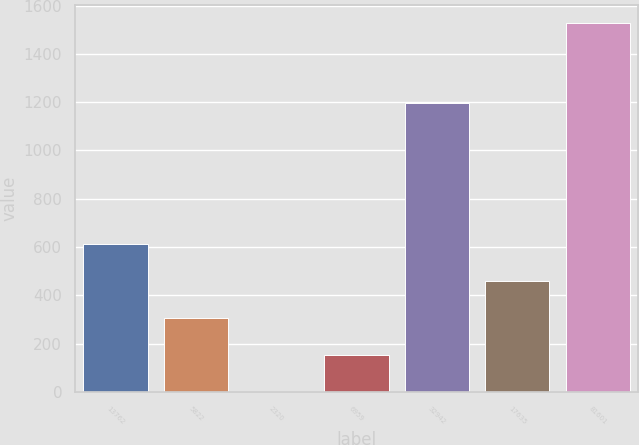<chart> <loc_0><loc_0><loc_500><loc_500><bar_chart><fcel>13762<fcel>5822<fcel>2320<fcel>6959<fcel>32942<fcel>17635<fcel>81601<nl><fcel>611.4<fcel>306.2<fcel>1<fcel>153.6<fcel>1196<fcel>458.8<fcel>1527<nl></chart> 